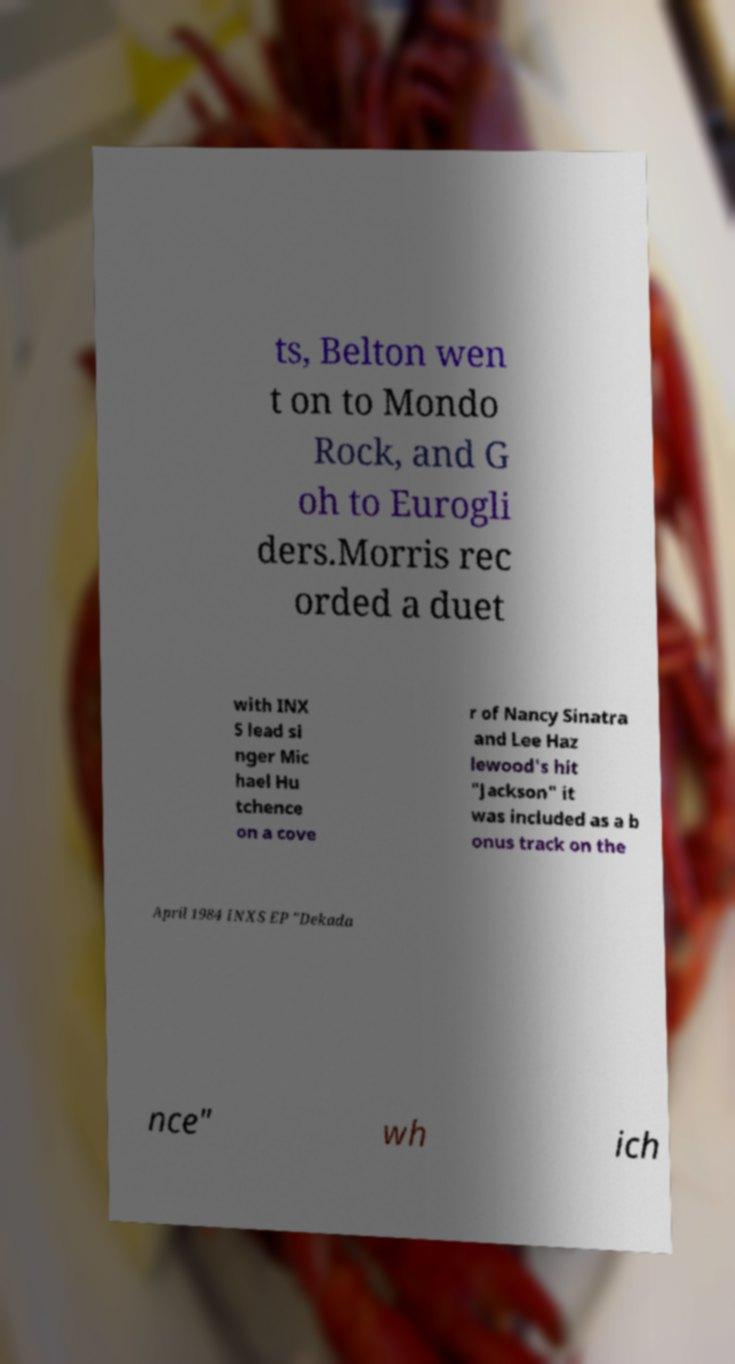Please identify and transcribe the text found in this image. ts, Belton wen t on to Mondo Rock, and G oh to Eurogli ders.Morris rec orded a duet with INX S lead si nger Mic hael Hu tchence on a cove r of Nancy Sinatra and Lee Haz lewood's hit "Jackson" it was included as a b onus track on the April 1984 INXS EP "Dekada nce" wh ich 